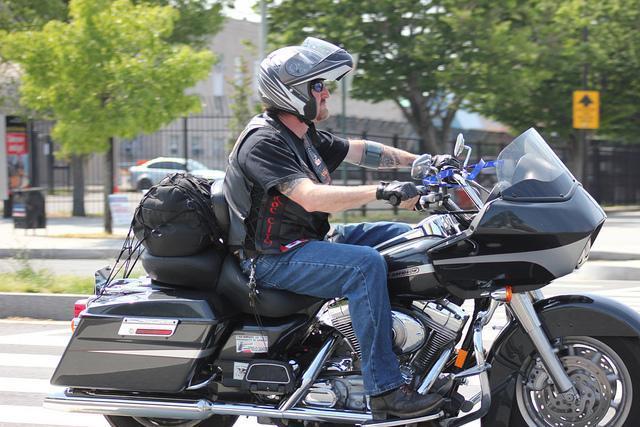How many people are on the bike?
Give a very brief answer. 1. 